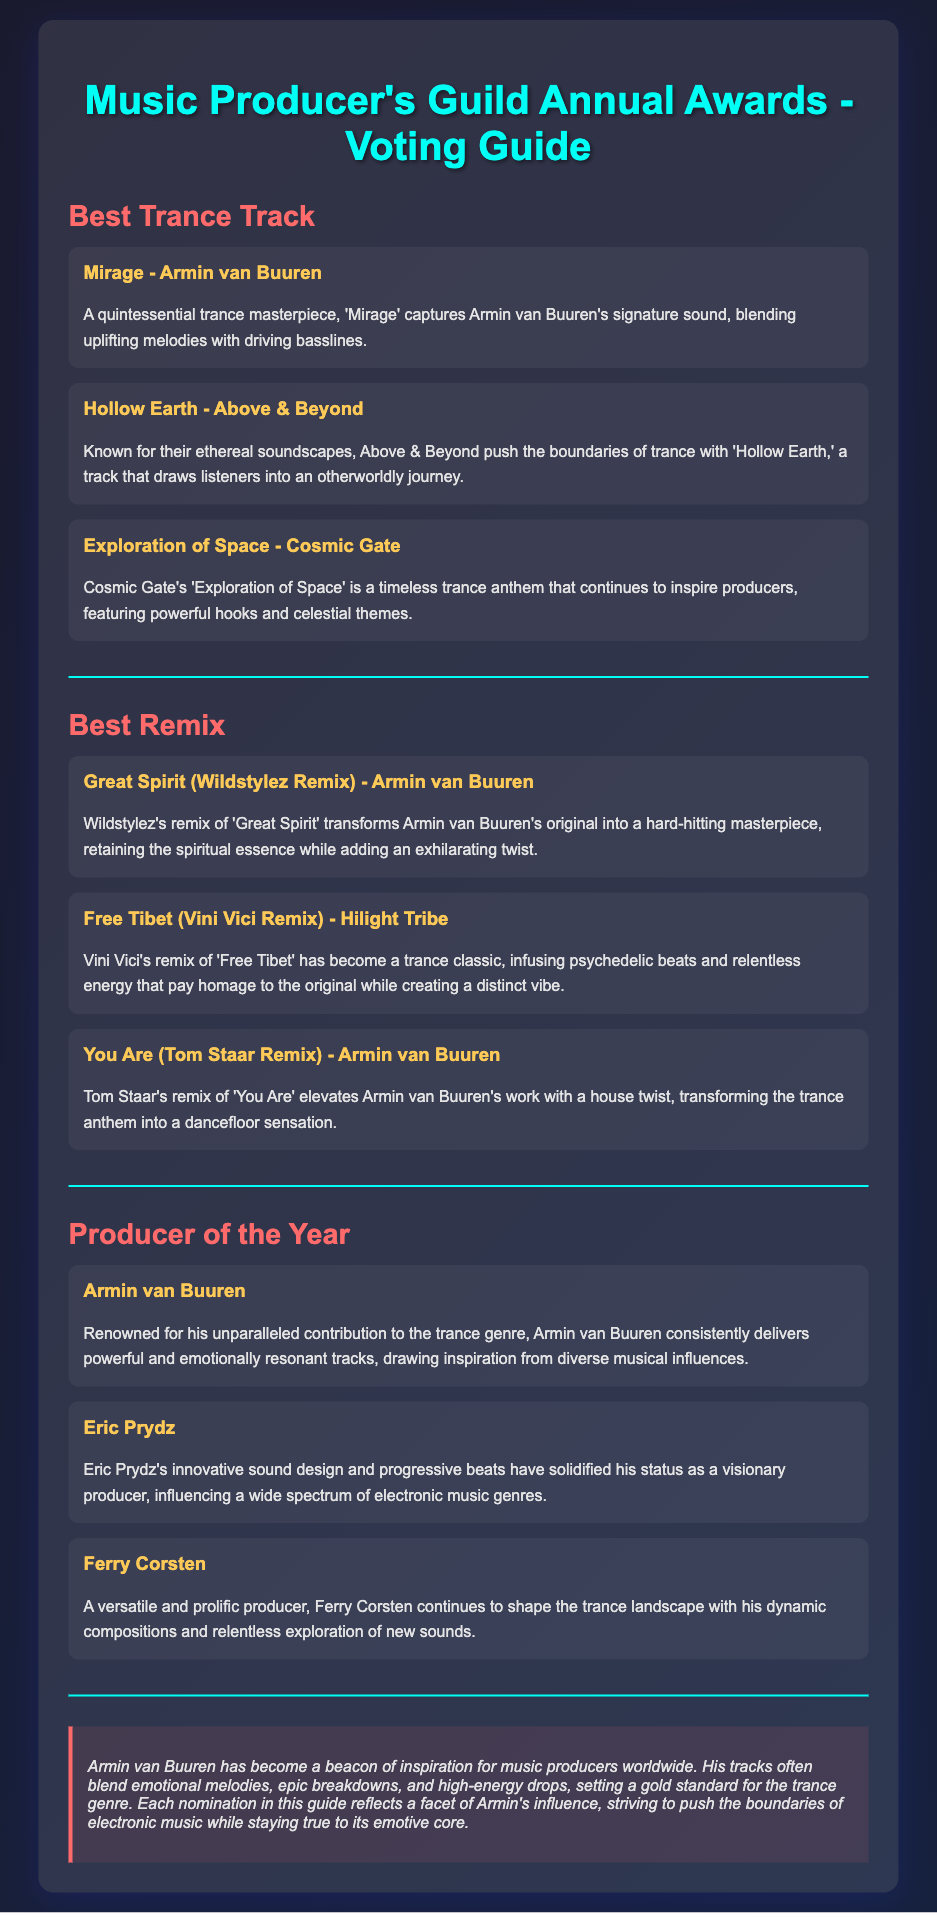What is the title of the voting guide? The document is titled "Music Producer's Guild Annual Awards - Voting Guide."
Answer: Music Producer's Guild Annual Awards - Voting Guide Who is one of the nominees for Best Trance Track? The document lists "Mirage - Armin van Buuren" as one of the nominees in this category.
Answer: Mirage - Armin van Buuren Which remix is nominated in the Best Remix category? "Great Spirit (Wildstylez Remix) - Armin van Buuren" is nominated for Best Remix according to the document.
Answer: Great Spirit (Wildstylez Remix) - Armin van Buuren Who is the Producer of the Year nominee known for sound design? "Eric Prydz" is recognized for his innovative sound design as a nominee for Producer of the Year.
Answer: Eric Prydz What genre does Armin van Buuren primarily contribute to? Armin van Buuren is renowned for his contribution to the trance genre in the document.
Answer: Trance What element is highlighted in Armin van Buuren's influence? The document mentions "emotional melodies" as a key element of Armin van Buuren's influence in his tracks.
Answer: Emotional melodies How many nominees are there for Best Trance Track? There are three nominees listed for the Best Trance Track category in the document.
Answer: Three Which nominee's remix retains the spiritual essence? The document states that Wildstylez's remix of "Great Spirit" retains the spiritual essence while adding a twist.
Answer: Wildstylez What color is used for the heading "Best Remix"? The color used for the heading "Best Remix" is ff6b6b according to the document's styling.
Answer: ff6b6b 